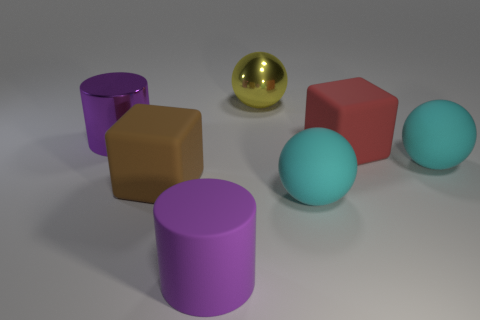Add 2 big gray shiny spheres. How many objects exist? 9 Subtract all spheres. How many objects are left? 4 Add 2 purple metallic cylinders. How many purple metallic cylinders exist? 3 Subtract 0 red cylinders. How many objects are left? 7 Subtract all purple rubber things. Subtract all large cylinders. How many objects are left? 4 Add 1 yellow shiny objects. How many yellow shiny objects are left? 2 